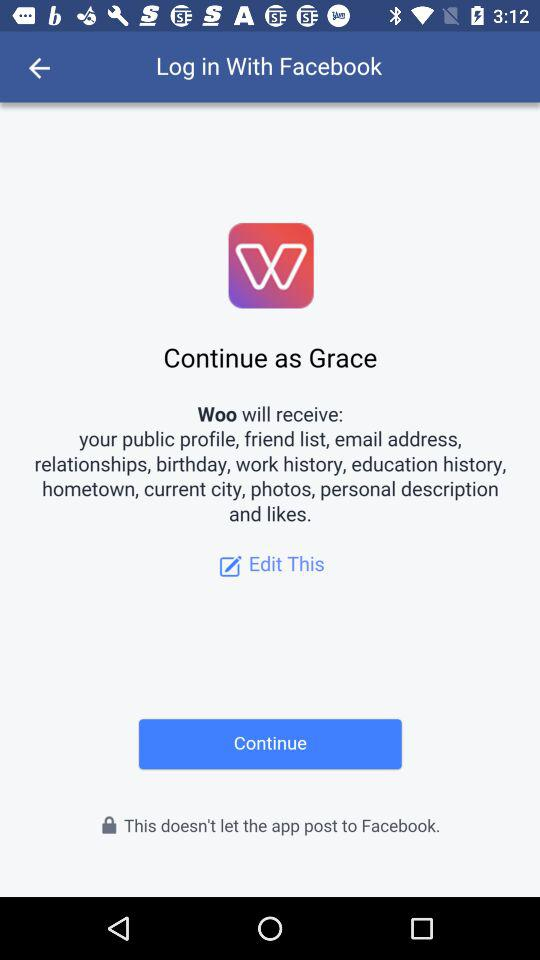Through what application can we log in? You can log in with "Facebook". 